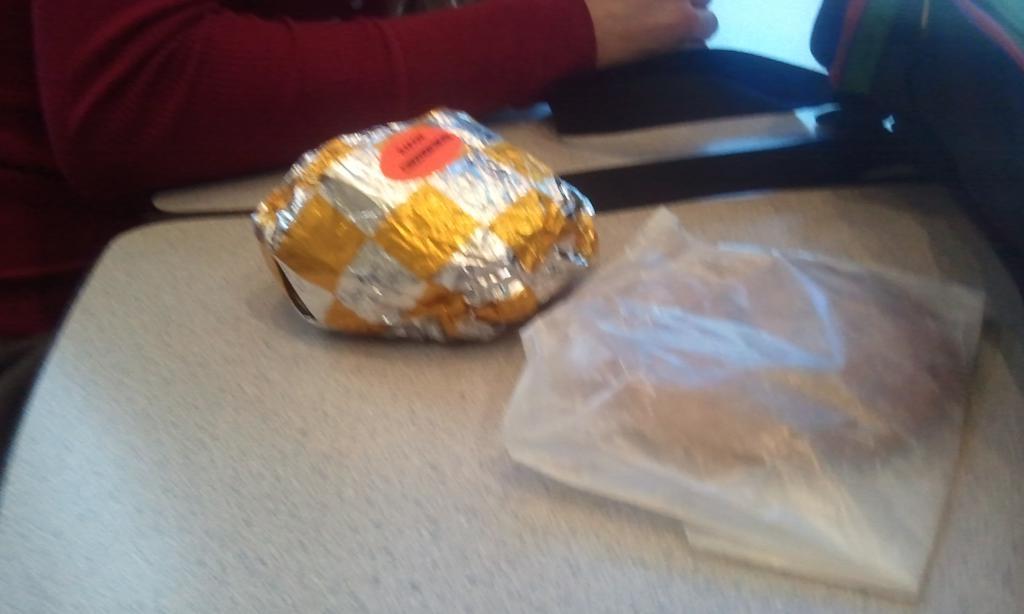Could you give a brief overview of what you see in this image? In this image, we can see some tables. We can see some objects covered with covers. We can see the hand of a person and an object on the right. We can also see an object at the top right corner. 